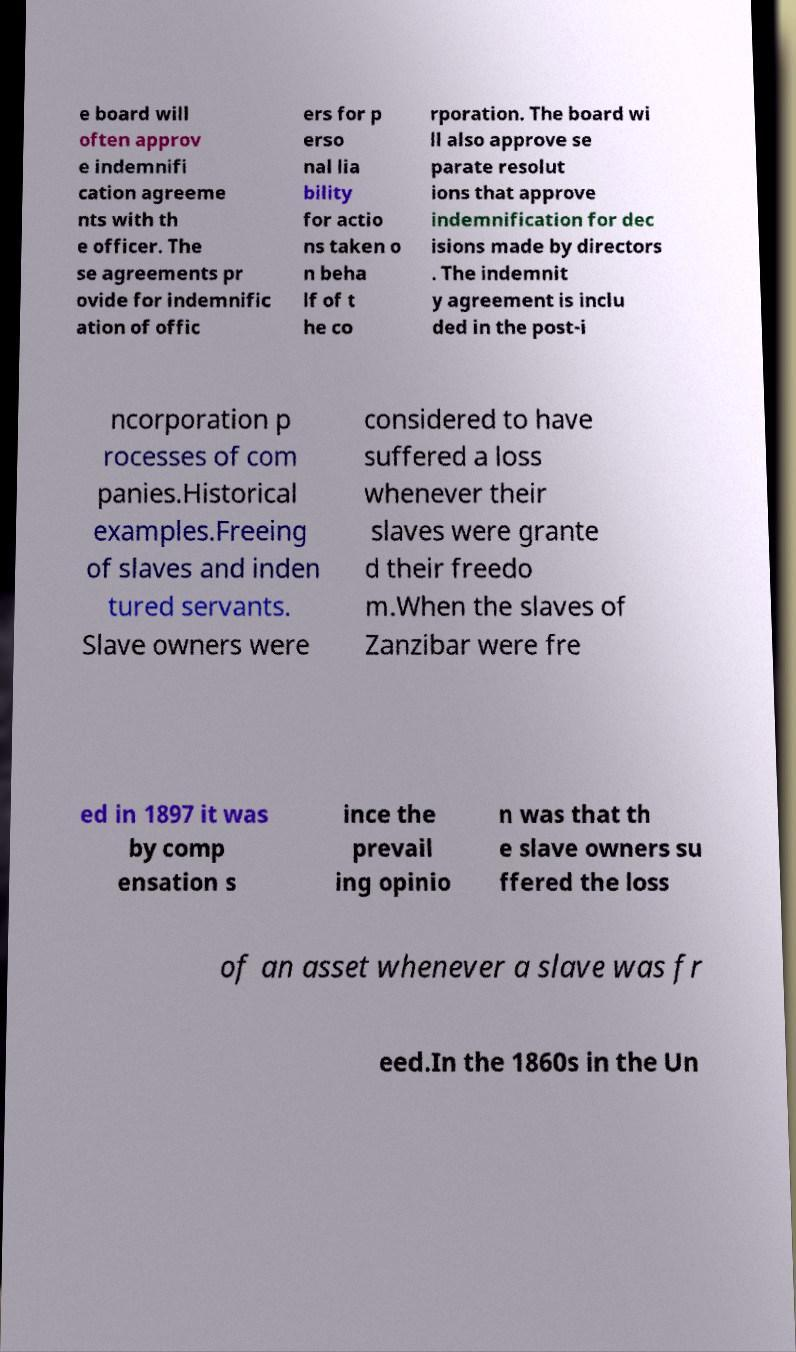Please read and relay the text visible in this image. What does it say? e board will often approv e indemnifi cation agreeme nts with th e officer. The se agreements pr ovide for indemnific ation of offic ers for p erso nal lia bility for actio ns taken o n beha lf of t he co rporation. The board wi ll also approve se parate resolut ions that approve indemnification for dec isions made by directors . The indemnit y agreement is inclu ded in the post-i ncorporation p rocesses of com panies.Historical examples.Freeing of slaves and inden tured servants. Slave owners were considered to have suffered a loss whenever their slaves were grante d their freedo m.When the slaves of Zanzibar were fre ed in 1897 it was by comp ensation s ince the prevail ing opinio n was that th e slave owners su ffered the loss of an asset whenever a slave was fr eed.In the 1860s in the Un 